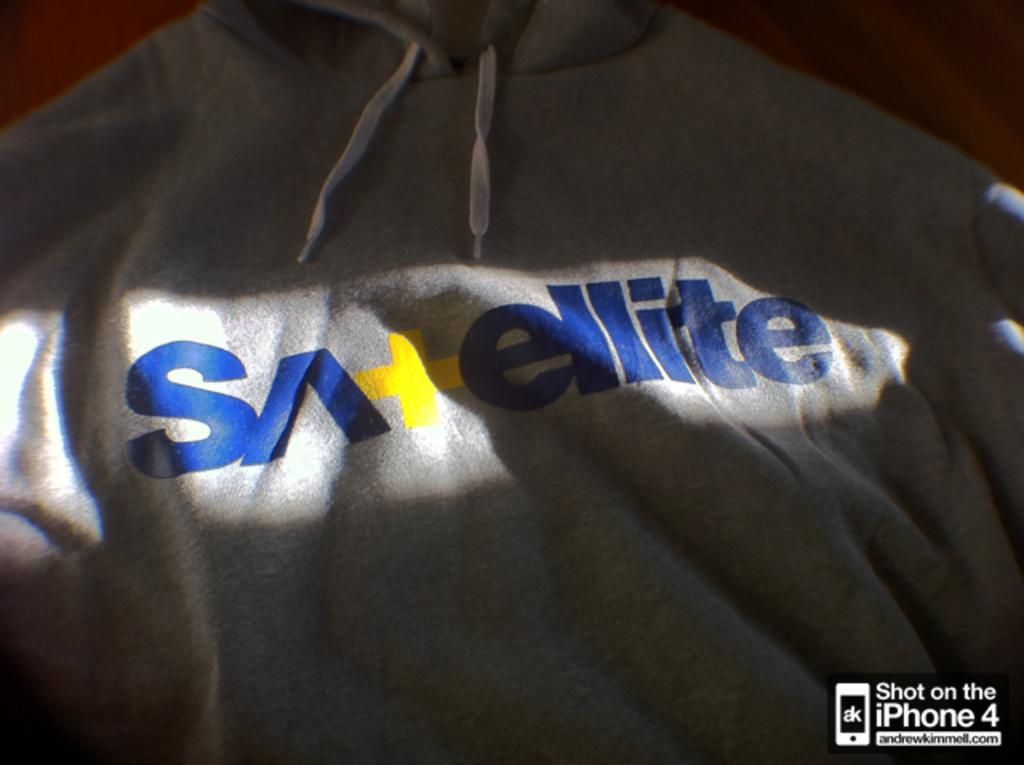<image>
Share a concise interpretation of the image provided. A grey sweatshirt has the word Satellite written in blue and yellow across it. 